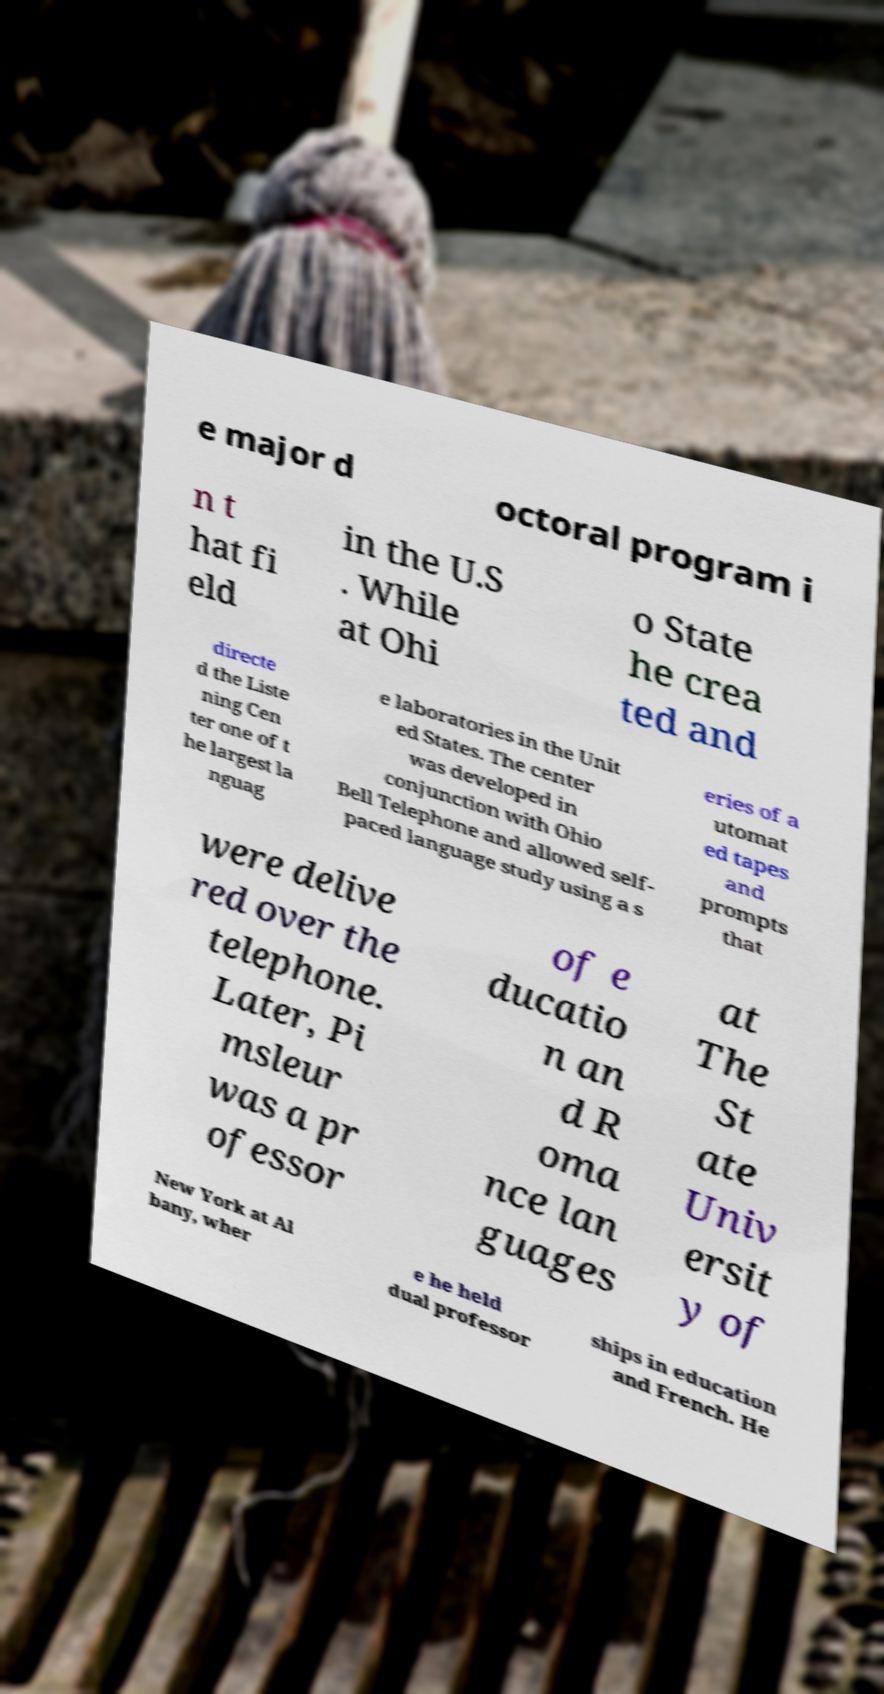Could you extract and type out the text from this image? e major d octoral program i n t hat fi eld in the U.S . While at Ohi o State he crea ted and directe d the Liste ning Cen ter one of t he largest la nguag e laboratories in the Unit ed States. The center was developed in conjunction with Ohio Bell Telephone and allowed self- paced language study using a s eries of a utomat ed tapes and prompts that were delive red over the telephone. Later, Pi msleur was a pr ofessor of e ducatio n an d R oma nce lan guages at The St ate Univ ersit y of New York at Al bany, wher e he held dual professor ships in education and French. He 